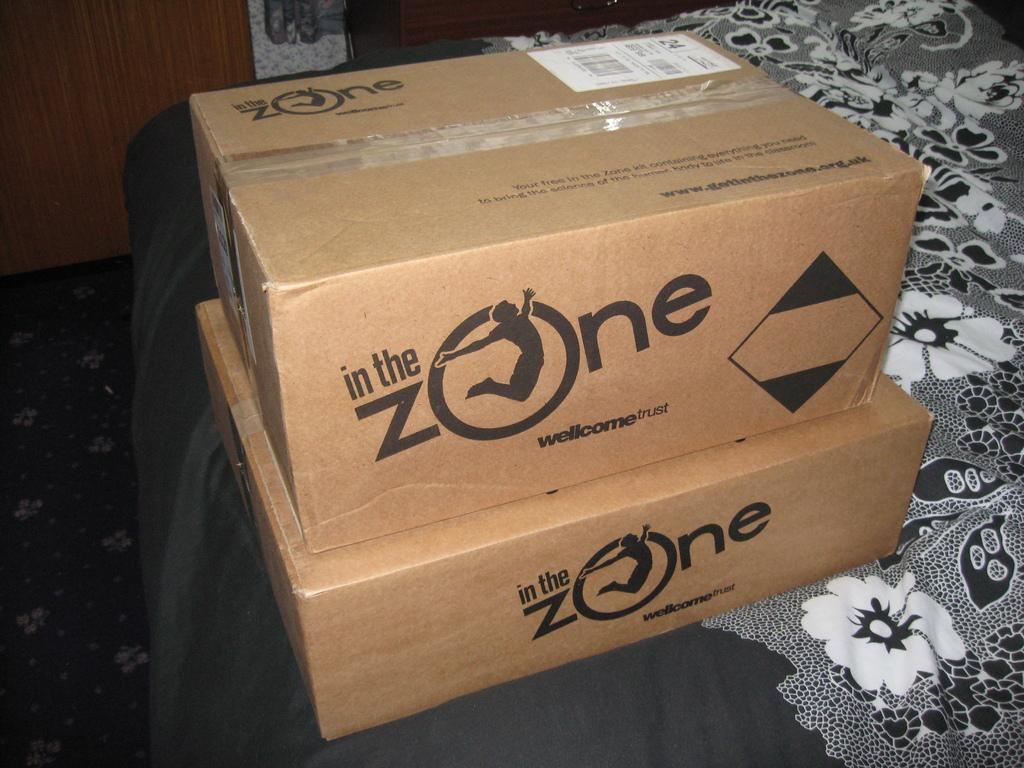Provide a one-sentence caption for the provided image. Two boxes are stacked on top of each other that are labeled In the Zone. 